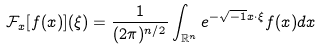<formula> <loc_0><loc_0><loc_500><loc_500>\mathcal { F } _ { x } [ f ( x ) ] ( \xi ) = \frac { 1 } { ( 2 \pi ) ^ { n / 2 } } \int _ { \mathbb { R } ^ { n } } e ^ { - \sqrt { - 1 } x \cdot \xi } f ( x ) d x</formula> 